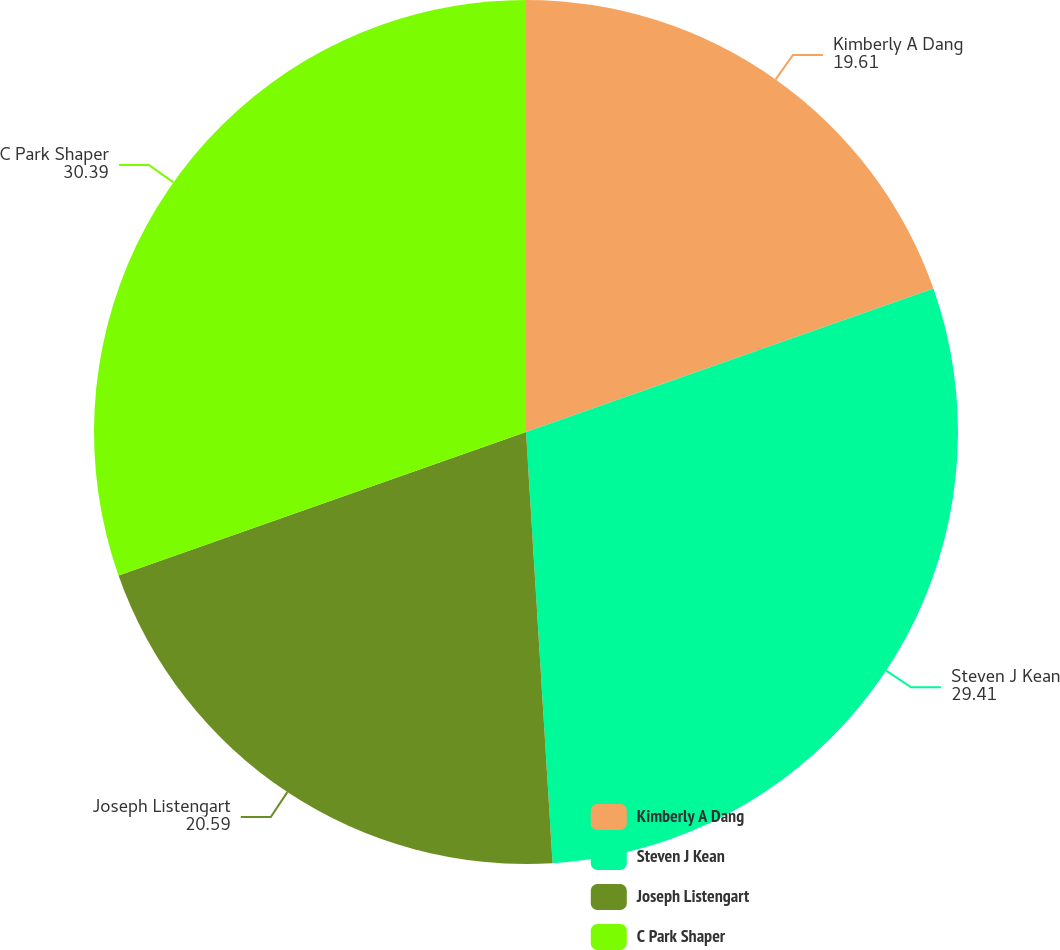Convert chart. <chart><loc_0><loc_0><loc_500><loc_500><pie_chart><fcel>Kimberly A Dang<fcel>Steven J Kean<fcel>Joseph Listengart<fcel>C Park Shaper<nl><fcel>19.61%<fcel>29.41%<fcel>20.59%<fcel>30.39%<nl></chart> 